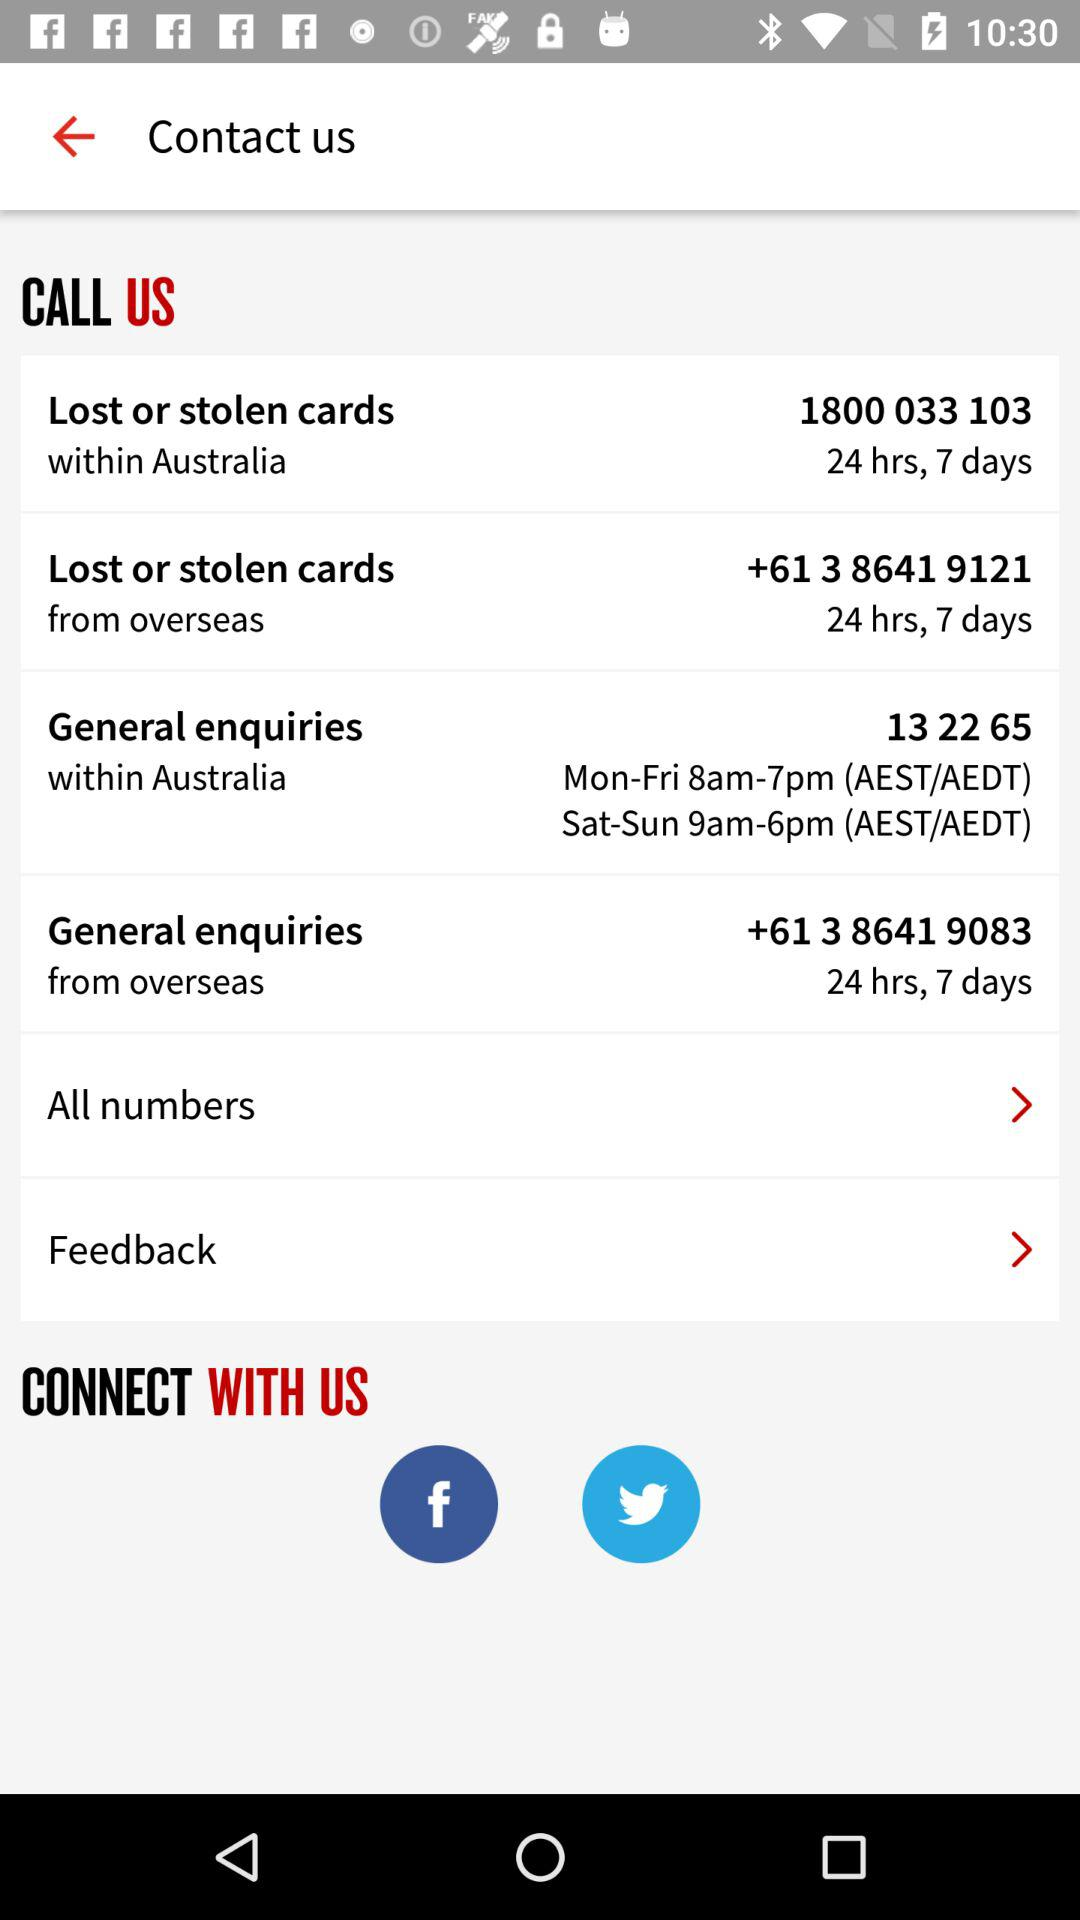What account can I use to connect with them? You can use "Facebook" and "Twitter". 